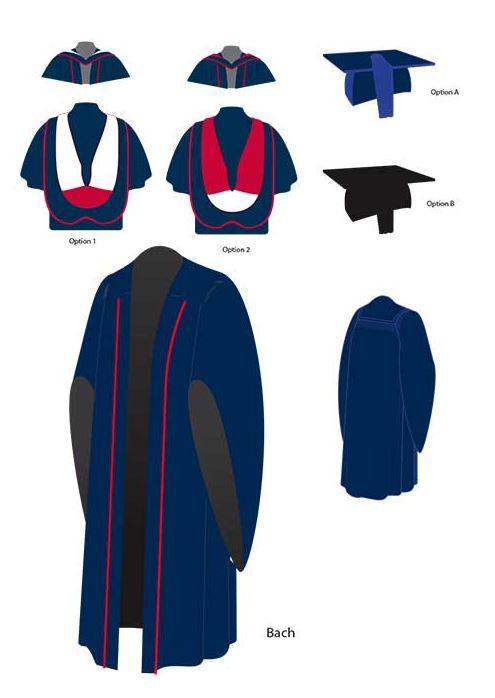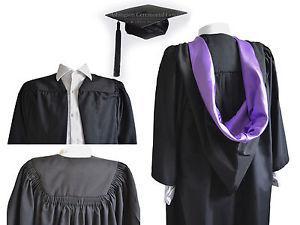The first image is the image on the left, the second image is the image on the right. Considering the images on both sides, is "In one image, the gown is accessorized with a red scarf worn around the neck, hanging open at the waist." valid? Answer yes or no. No. 